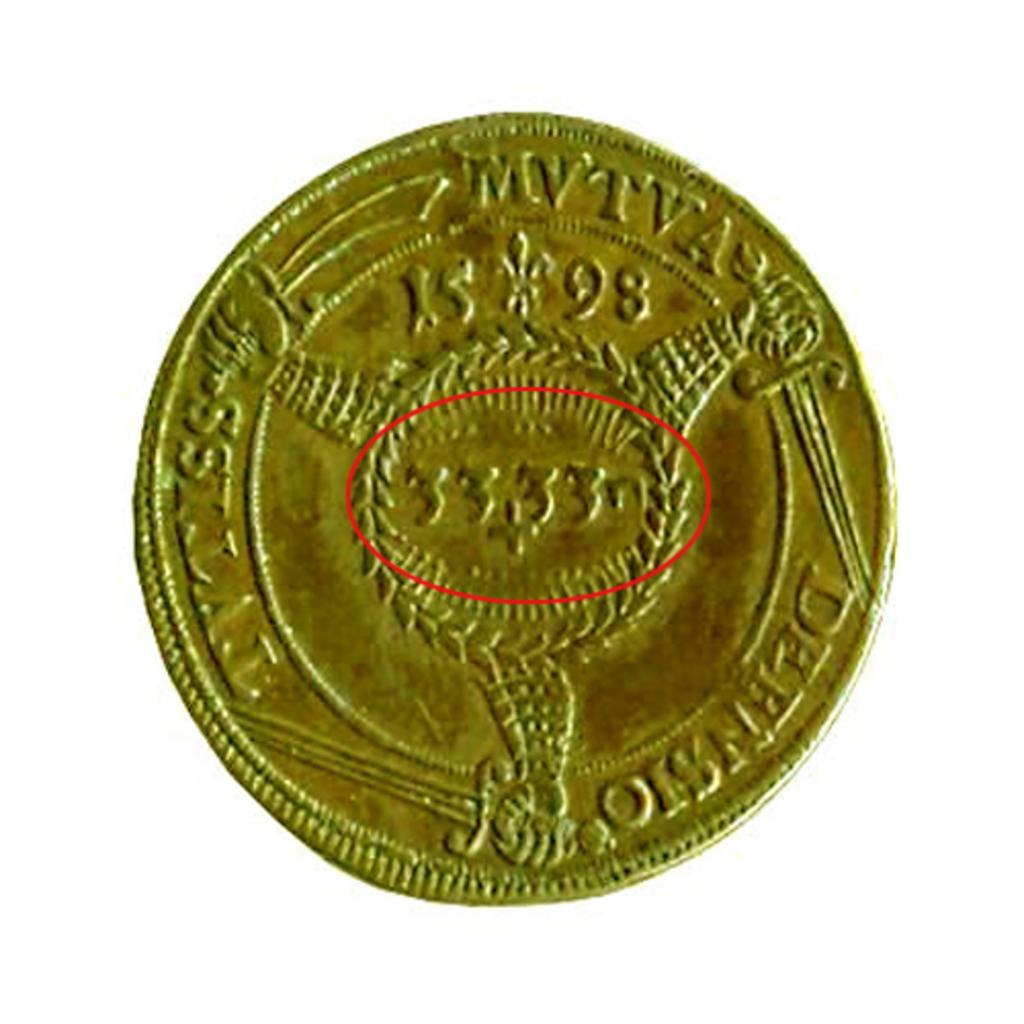What year is printed on the coin?
Ensure brevity in your answer.  1598. What number is the coin?
Provide a short and direct response. 3333. 